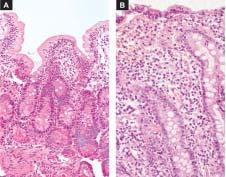s viral rna genome as well as reverse transcriptase near total flattening of the villi and crypt hyperplasia?
Answer the question using a single word or phrase. No 